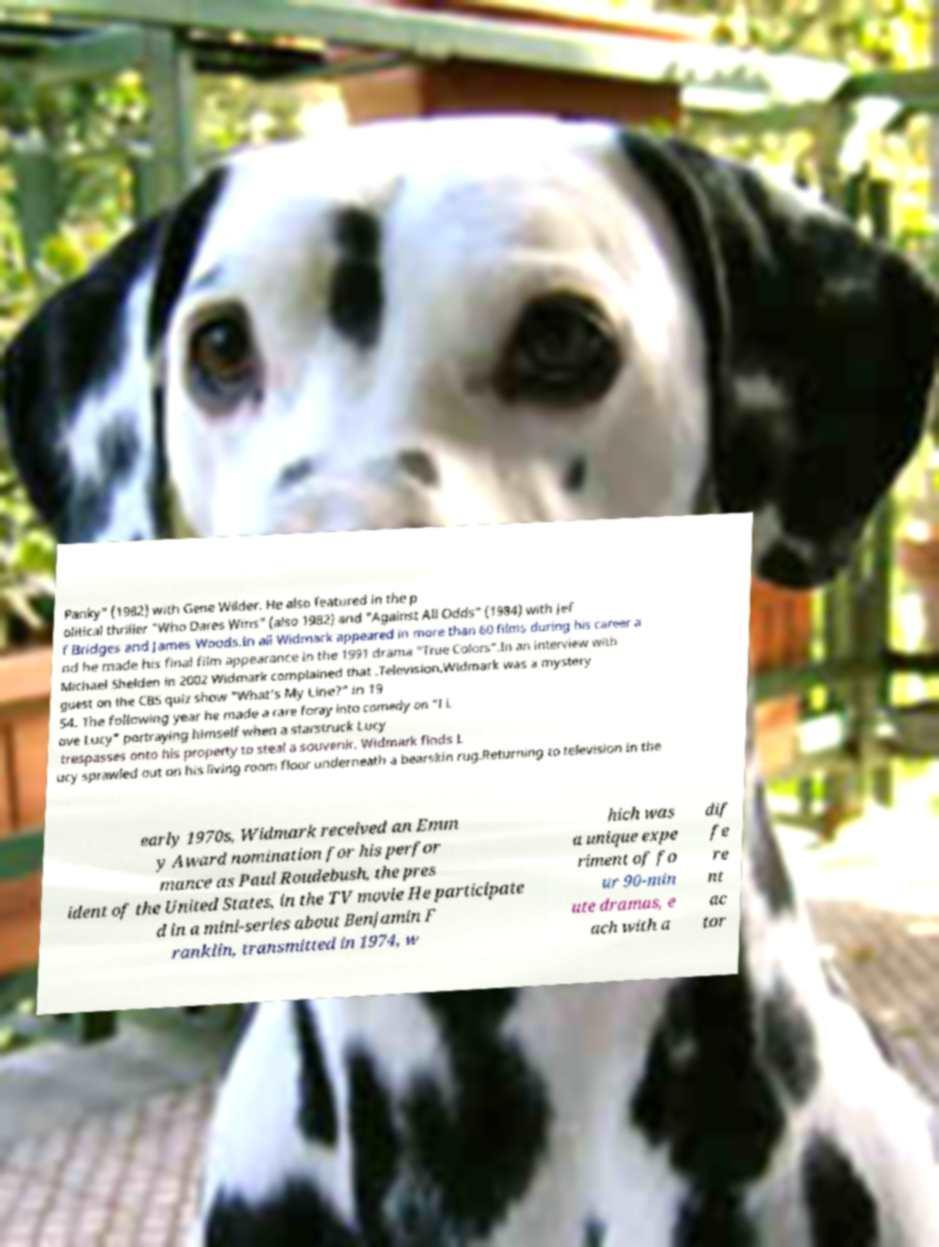Can you accurately transcribe the text from the provided image for me? Panky" (1982) with Gene Wilder. He also featured in the p olitical thriller "Who Dares Wins" (also 1982) and "Against All Odds" (1984) with Jef f Bridges and James Woods.In all Widmark appeared in more than 60 films during his career a nd he made his final film appearance in the 1991 drama "True Colors".In an interview with Michael Shelden in 2002 Widmark complained that .Television.Widmark was a mystery guest on the CBS quiz show "What's My Line?" in 19 54. The following year he made a rare foray into comedy on "I L ove Lucy" portraying himself when a starstruck Lucy trespasses onto his property to steal a souvenir. Widmark finds L ucy sprawled out on his living room floor underneath a bearskin rug.Returning to television in the early 1970s, Widmark received an Emm y Award nomination for his perfor mance as Paul Roudebush, the pres ident of the United States, in the TV movie He participate d in a mini-series about Benjamin F ranklin, transmitted in 1974, w hich was a unique expe riment of fo ur 90-min ute dramas, e ach with a dif fe re nt ac tor 